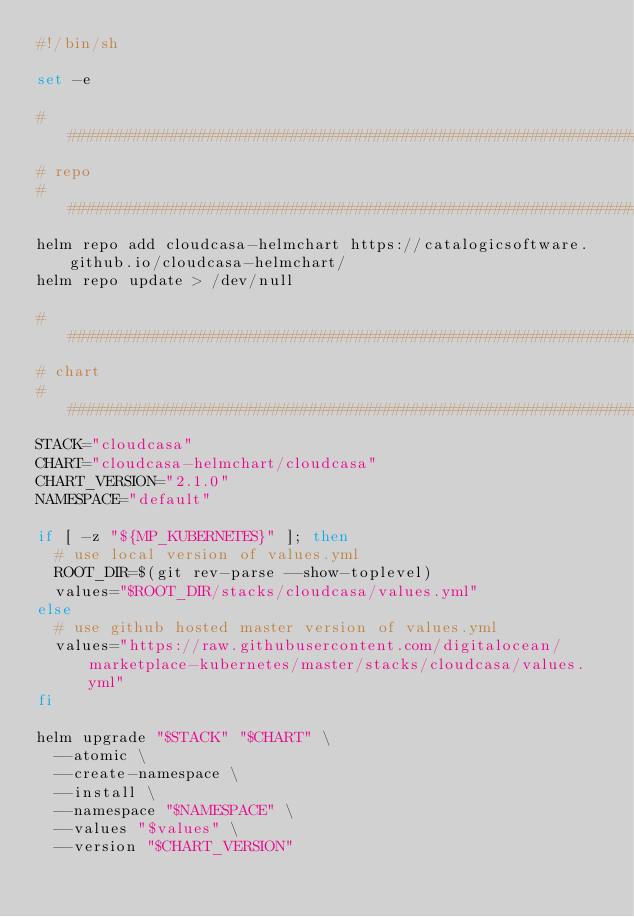Convert code to text. <code><loc_0><loc_0><loc_500><loc_500><_Bash_>#!/bin/sh

set -e

################################################################################
# repo
################################################################################
helm repo add cloudcasa-helmchart https://catalogicsoftware.github.io/cloudcasa-helmchart/
helm repo update > /dev/null

################################################################################
# chart
################################################################################
STACK="cloudcasa"
CHART="cloudcasa-helmchart/cloudcasa"
CHART_VERSION="2.1.0"
NAMESPACE="default"

if [ -z "${MP_KUBERNETES}" ]; then
  # use local version of values.yml
  ROOT_DIR=$(git rev-parse --show-toplevel)
  values="$ROOT_DIR/stacks/cloudcasa/values.yml"
else
  # use github hosted master version of values.yml
  values="https://raw.githubusercontent.com/digitalocean/marketplace-kubernetes/master/stacks/cloudcasa/values.yml"
fi

helm upgrade "$STACK" "$CHART" \
  --atomic \
  --create-namespace \
  --install \
  --namespace "$NAMESPACE" \
  --values "$values" \
  --version "$CHART_VERSION"
</code> 